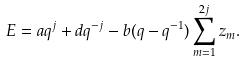<formula> <loc_0><loc_0><loc_500><loc_500>E = a q ^ { j } + d q ^ { - j } - b ( q - q ^ { - 1 } ) \sum _ { m = 1 } ^ { 2 j } z _ { m } .</formula> 